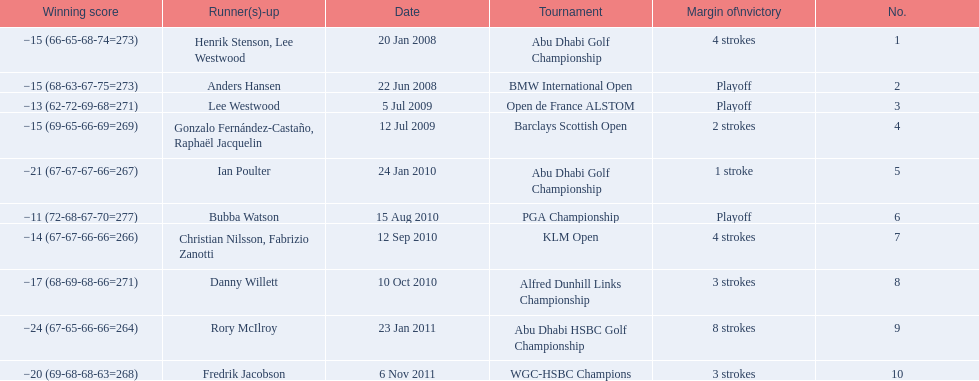What were all of the tournaments martin played in? Abu Dhabi Golf Championship, BMW International Open, Open de France ALSTOM, Barclays Scottish Open, Abu Dhabi Golf Championship, PGA Championship, KLM Open, Alfred Dunhill Links Championship, Abu Dhabi HSBC Golf Championship, WGC-HSBC Champions. And how many strokes did he score? −15 (66-65-68-74=273), −15 (68-63-67-75=273), −13 (62-72-69-68=271), −15 (69-65-66-69=269), −21 (67-67-67-66=267), −11 (72-68-67-70=277), −14 (67-67-66-66=266), −17 (68-69-68-66=271), −24 (67-65-66-66=264), −20 (69-68-68-63=268). What about during barclays and klm? −15 (69-65-66-69=269), −14 (67-67-66-66=266). How many more were scored in klm? 2 strokes. 